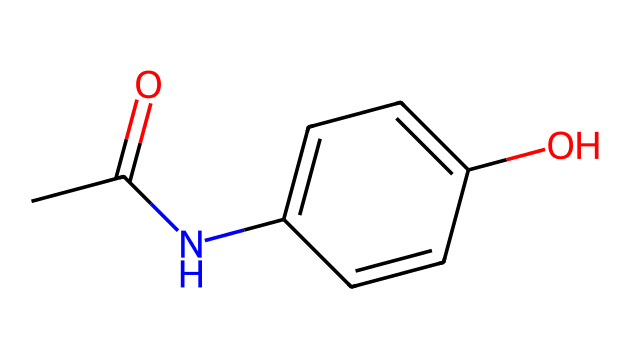What is the molecular formula of acetaminophen? From the SMILES representation (CC(=O)Nc1ccc(O)cc1), we can derive the molecular formula by counting each type of atom involved. Carbon (C) = 8, Hydrogen (H) = 9, Nitrogen (N) = 1, and Oxygen (O) = 2. Putting these together, we get C8H9N1O2, which simplifies to C8H9NO2.
Answer: C8H9NO2 How many cycloalkane structures are present in acetaminophen? By examining the SMILES, specifically the section "c1ccc(O)cc1," we identify a benzene ring, which is a cyclic structure. There are no additional cycloalkane structures present in the molecule. Thus, there is one cycloalkane structure, that is a benzene ring in acetaminophen.
Answer: 1 What functional groups are present in acetaminophen? Assessing the SMILES representation, we identify two functional groups: the amide group from the 'NC(=O)' portion (where N is nitrogen and C=O is carbonyl) and the hydroxyl group from 'O' attached to the benzene ring. Therefore, we can conclude that acetaminophen comprises an amide group and a hydroxyl group.
Answer: amide, hydroxyl How many hydroxyl groups are in acetaminophen? In the SMILES structure, the 'O' attached to the aromatic ring denotes a hydroxyl group (-OH). There is only one such group present in the structure of acetaminophen.
Answer: 1 What is the total number of hydrogen atoms attached to the carbon atoms in acetaminophen? The structure indicates that the molecules have eight carbon atoms. Based on the bonding and functional groups, we find there are nine hydrogen atoms attached to these carbon atoms in total, considering that one hydrogen is replaced by the nitrogen in the amide.
Answer: 9 Which specific portion of the acetaminophen chemical structure causes its analgesic property? The amide formation (from the nitrogen and the adjacent carbonyl group) is essential for the pain-relief properties of acetaminophen. This portion allows the drug to interact effectively with pain receptors in the body, thus enabling its analgesic effects.
Answer: amide group 